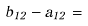<formula> <loc_0><loc_0><loc_500><loc_500>b _ { 1 2 } - a _ { 1 2 } =</formula> 